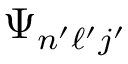Convert formula to latex. <formula><loc_0><loc_0><loc_500><loc_500>\Psi _ { n ^ { \prime } \ell ^ { \prime } j ^ { \prime } }</formula> 